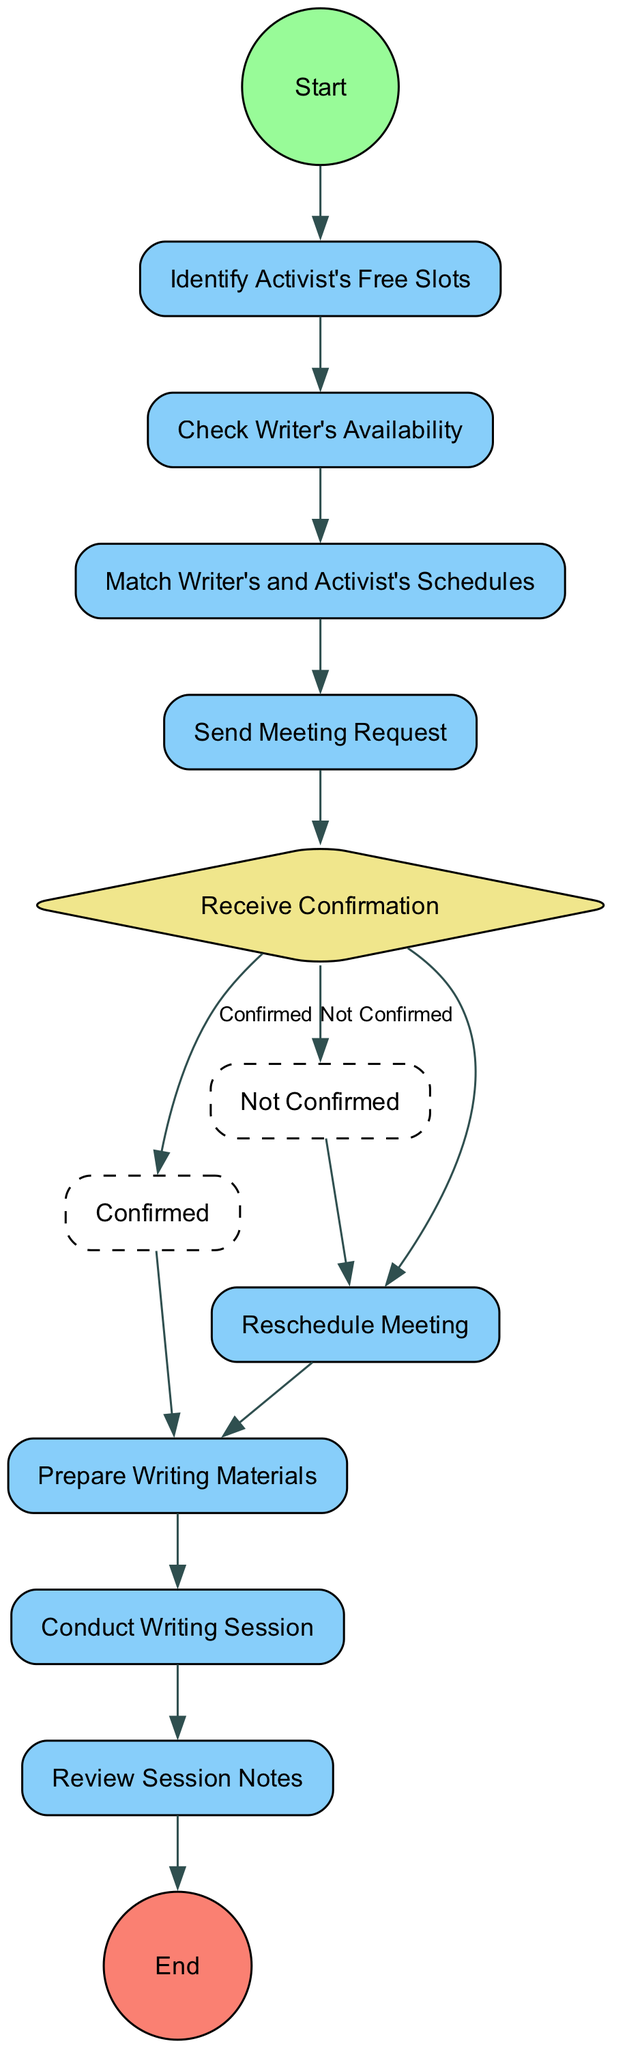What is the first action in the diagram? The diagram starts with the 'Start' node, which leads to the first action node labeled 'Identify Activist's Free Slots'. This indicates that the process begins with this specific action.
Answer: Identify Activist's Free Slots How many action nodes are there in the diagram? By counting all the nodes designated as actions in the activity diagram, there are a total of six action nodes. They include 'Identify Activist's Free Slots', 'Check Writer's Availability', 'Match Writer's and Activist's Schedules', 'Send Meeting Request', 'Prepare Writing Materials', and 'Conduct Writing Session'.
Answer: Six What decision occurs after sending the meeting request? The decision made after sending the meeting request is about receiving the confirmation of the meeting. This node is labeled 'Receive Confirmation' and branches into two possible paths.
Answer: Receive Confirmation If the meeting is confirmed, what are the subsequent actions? When the meeting is confirmed, the following actions are 'Prepare Writing Materials', 'Conduct Writing Session', and 'Review Session Notes'. These actions are directly connected to the 'Confirmed' branch from the decision node.
Answer: Prepare Writing Materials, Conduct Writing Session, Review Session Notes What happens if the meeting is not confirmed? If the meeting is not confirmed, the action that follows is 'Reschedule Meeting'. This connects directly from the 'Not Confirmed' branch of the decision node 'Receive Confirmation'.
Answer: Reschedule Meeting How does the writer determine when to schedule the writing session? The writer determines when to schedule the writing session by first identifying the activist's free slots and then checking their own availability. This dual approach ensures that both schedules align before proceeding to match them.
Answer: Match Writer's and Activist's Schedules Which node represents a decision point in the activity diagram? The node that represents a decision point in the activity diagram is 'Receive Confirmation'. It has two branches labeled 'Confirmed' and 'Not Confirmed', indicating the outcome of the meeting request.
Answer: Receive Confirmation How many branches does the decision 'Receive Confirmation' have? The decision 'Receive Confirmation' has two branches: 'Confirmed' and 'Not Confirmed'. These branches dictate the next steps based on whether the meeting request is accepted or not.
Answer: Two 